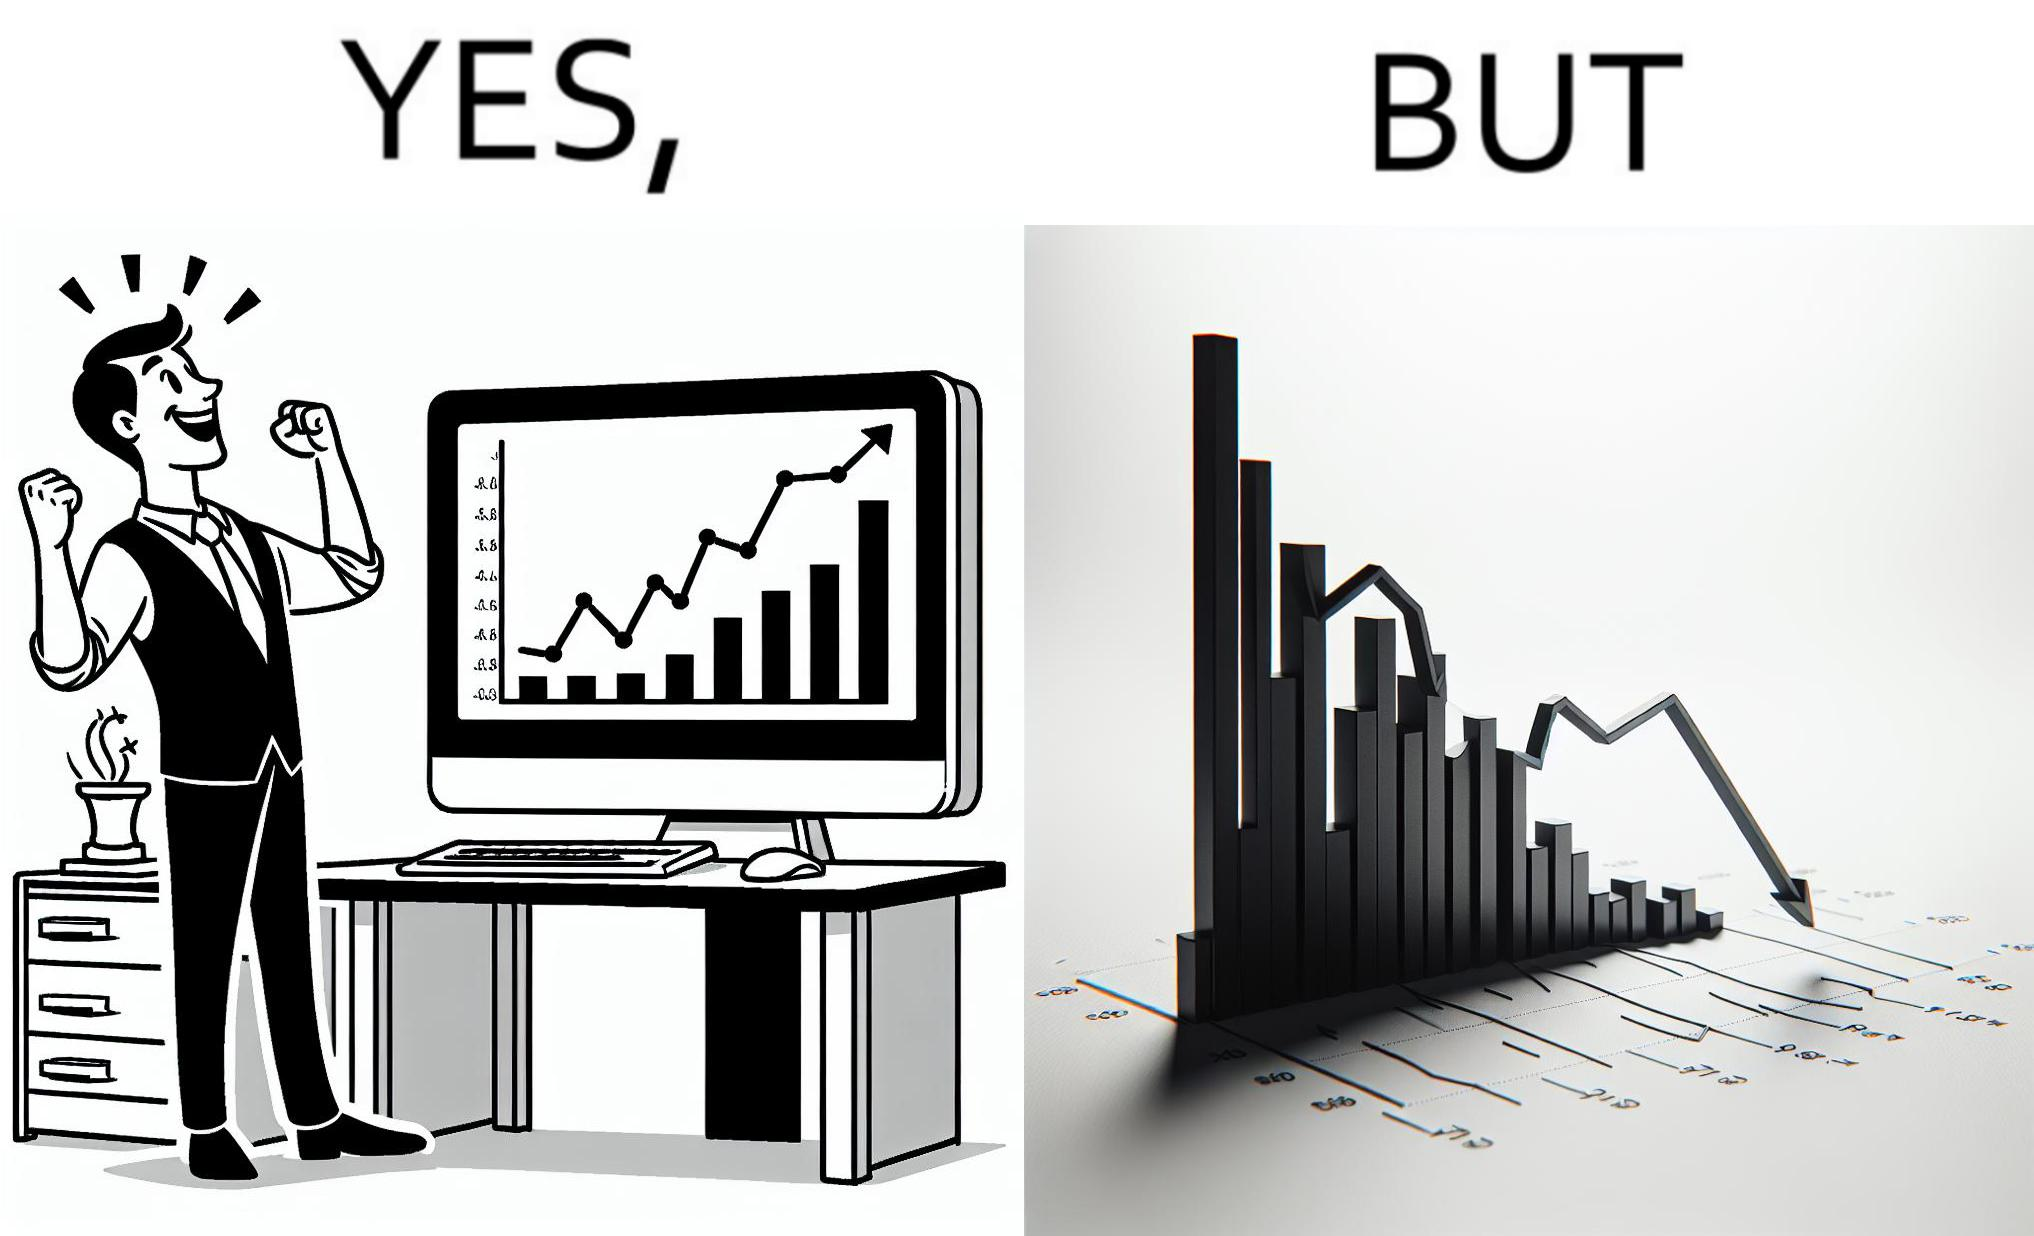What is shown in this image? The image is ironic, because a person is seen feeling proud over the profit earned over his investment but the right image shows the whole story how only a small part of his investment journey is shown and the other loss part is ignored 